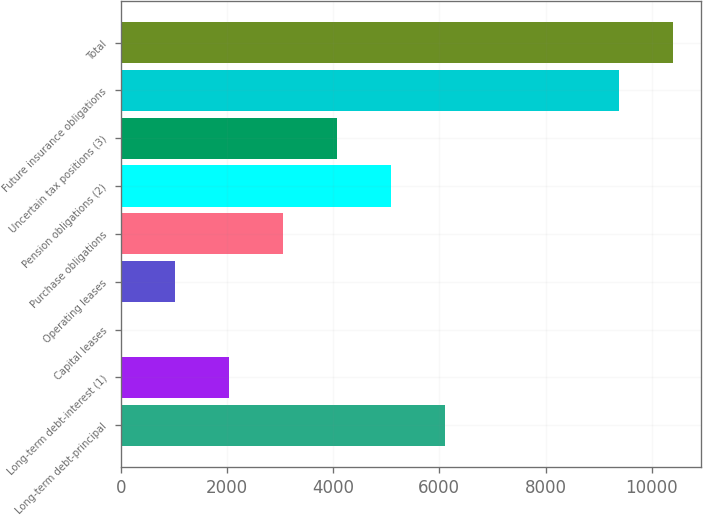Convert chart to OTSL. <chart><loc_0><loc_0><loc_500><loc_500><bar_chart><fcel>Long-term debt-principal<fcel>Long-term debt-interest (1)<fcel>Capital leases<fcel>Operating leases<fcel>Purchase obligations<fcel>Pension obligations (2)<fcel>Uncertain tax positions (3)<fcel>Future insurance obligations<fcel>Total<nl><fcel>6114.83<fcel>2038.63<fcel>0.53<fcel>1019.58<fcel>3057.68<fcel>5095.78<fcel>4076.73<fcel>9382<fcel>10401<nl></chart> 